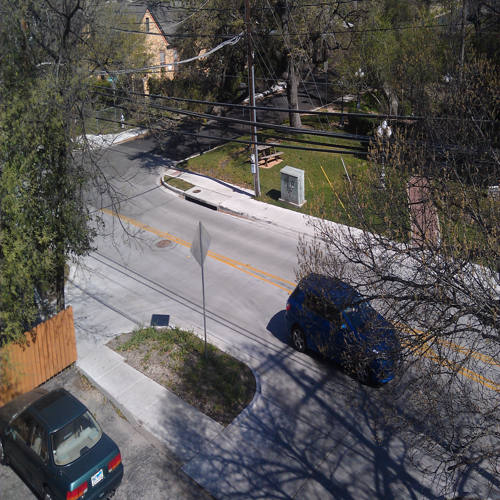Can you describe the weather or time of day in this image? The weather appears to be fair and the shadows suggest it is either late morning or early afternoon. There's ample sunlight, clear skies, and the shadows cast by the trees and vehicles demonstrate that it is a sunny day, which can be indicative of the sun's position in the sky during these times. 